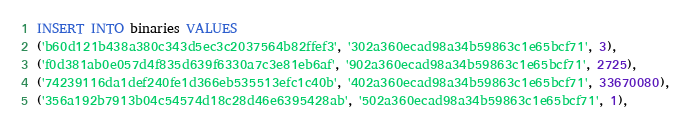Convert code to text. <code><loc_0><loc_0><loc_500><loc_500><_SQL_>INSERT INTO binaries VALUES
('b60d121b438a380c343d5ec3c2037564b82ffef3', '302a360ecad98a34b59863c1e65bcf71', 3),
('f0d381ab0e057d4f835d639f6330a7c3e81eb6af', '902a360ecad98a34b59863c1e65bcf71', 2725),
('74239116da1def240fe1d366eb535513efc1c40b', '402a360ecad98a34b59863c1e65bcf71', 33670080),
('356a192b7913b04c54574d18c28d46e6395428ab', '502a360ecad98a34b59863c1e65bcf71', 1),</code> 